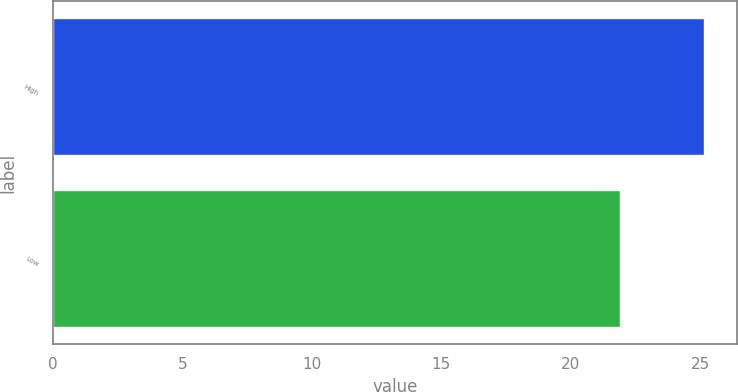Convert chart to OTSL. <chart><loc_0><loc_0><loc_500><loc_500><bar_chart><fcel>High<fcel>Low<nl><fcel>25.16<fcel>21.89<nl></chart> 